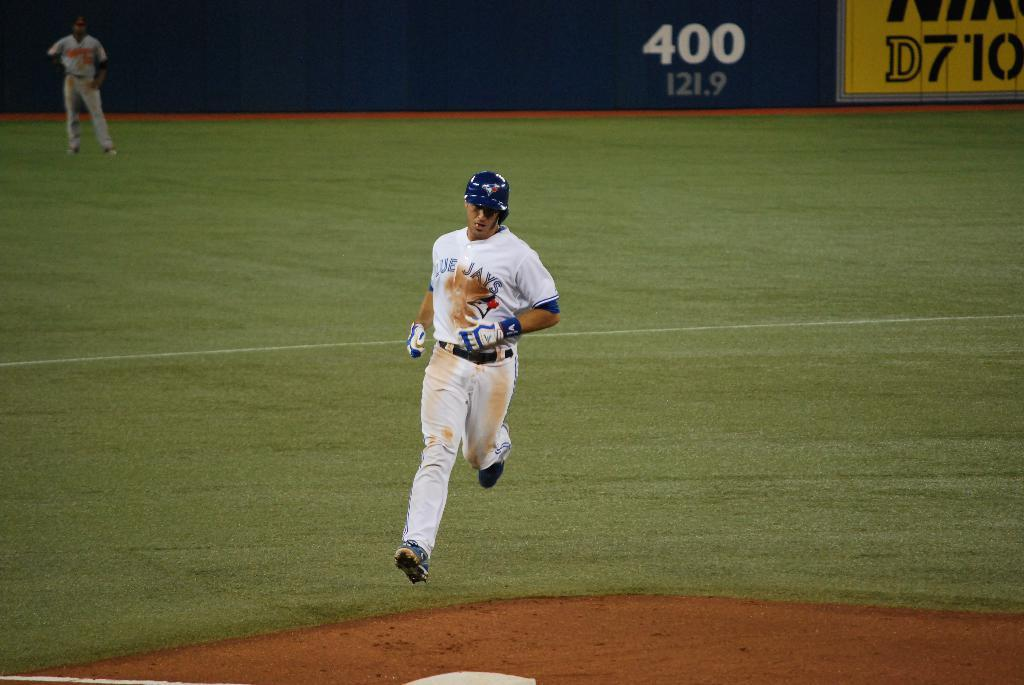<image>
Create a compact narrative representing the image presented. A Blue Jay's baseball player running to base wearing his helmet and showing a player in the outfield. 